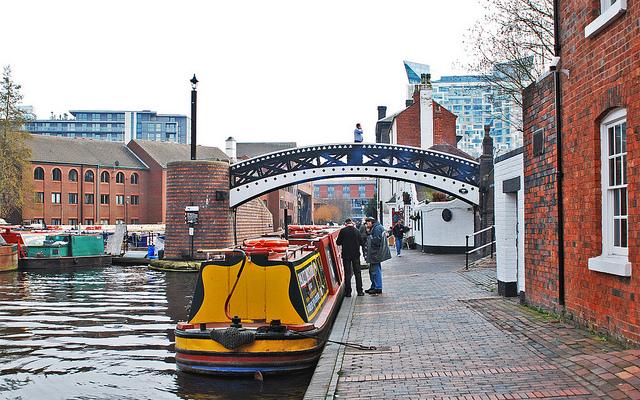What kind of boat is this?
Short answer required. Ferry. Is this in the United States?
Keep it brief. No. Where are the people?
Short answer required. On sidewalk. 